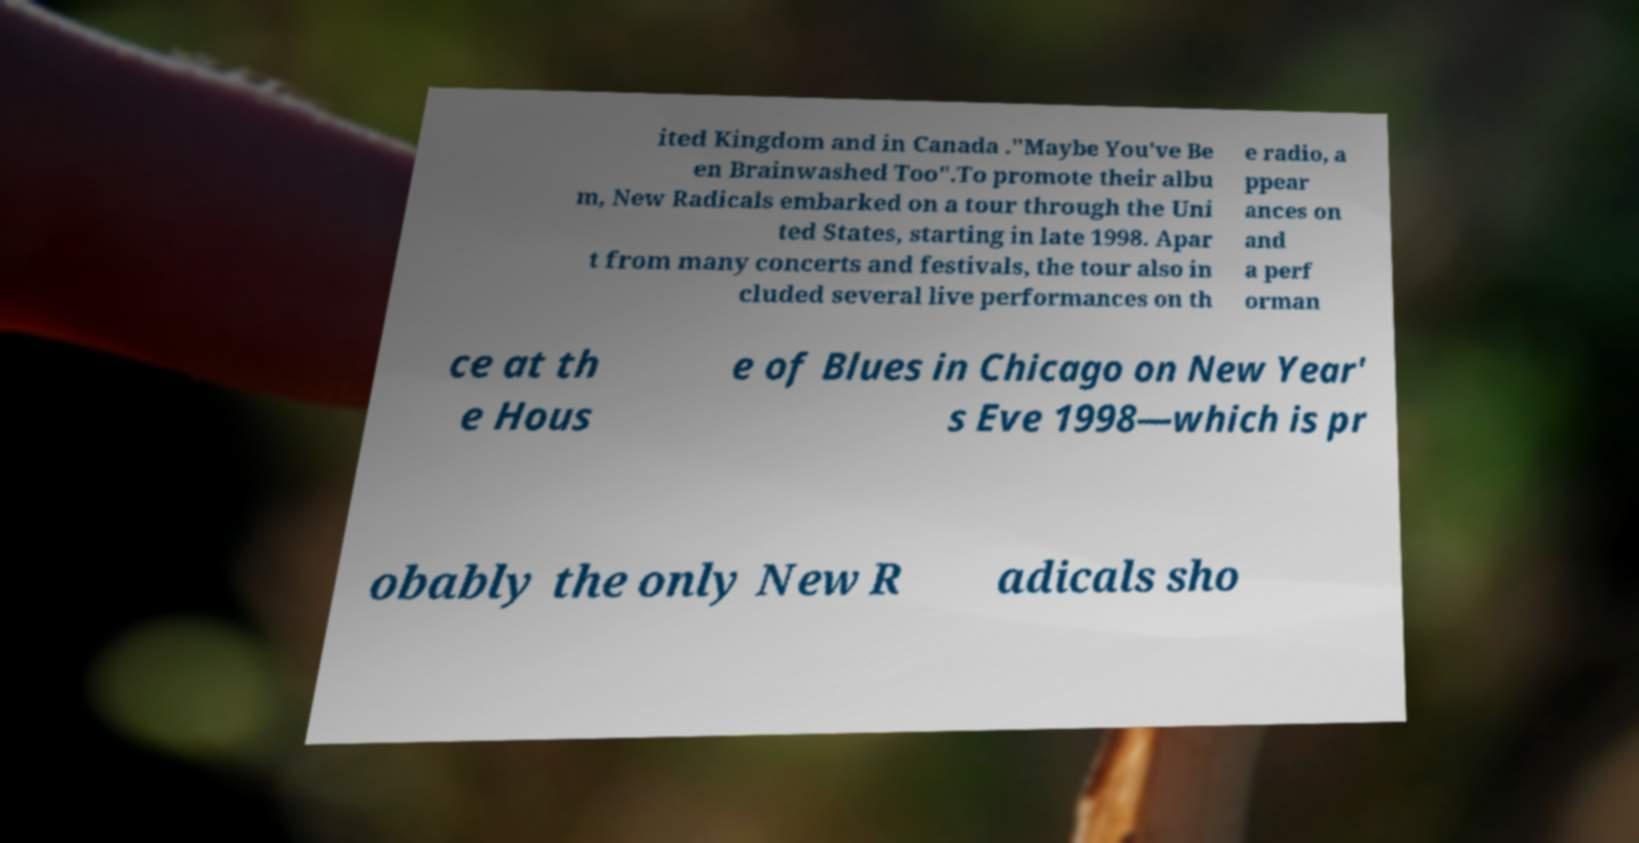Please read and relay the text visible in this image. What does it say? ited Kingdom and in Canada ."Maybe You've Be en Brainwashed Too".To promote their albu m, New Radicals embarked on a tour through the Uni ted States, starting in late 1998. Apar t from many concerts and festivals, the tour also in cluded several live performances on th e radio, a ppear ances on and a perf orman ce at th e Hous e of Blues in Chicago on New Year' s Eve 1998—which is pr obably the only New R adicals sho 